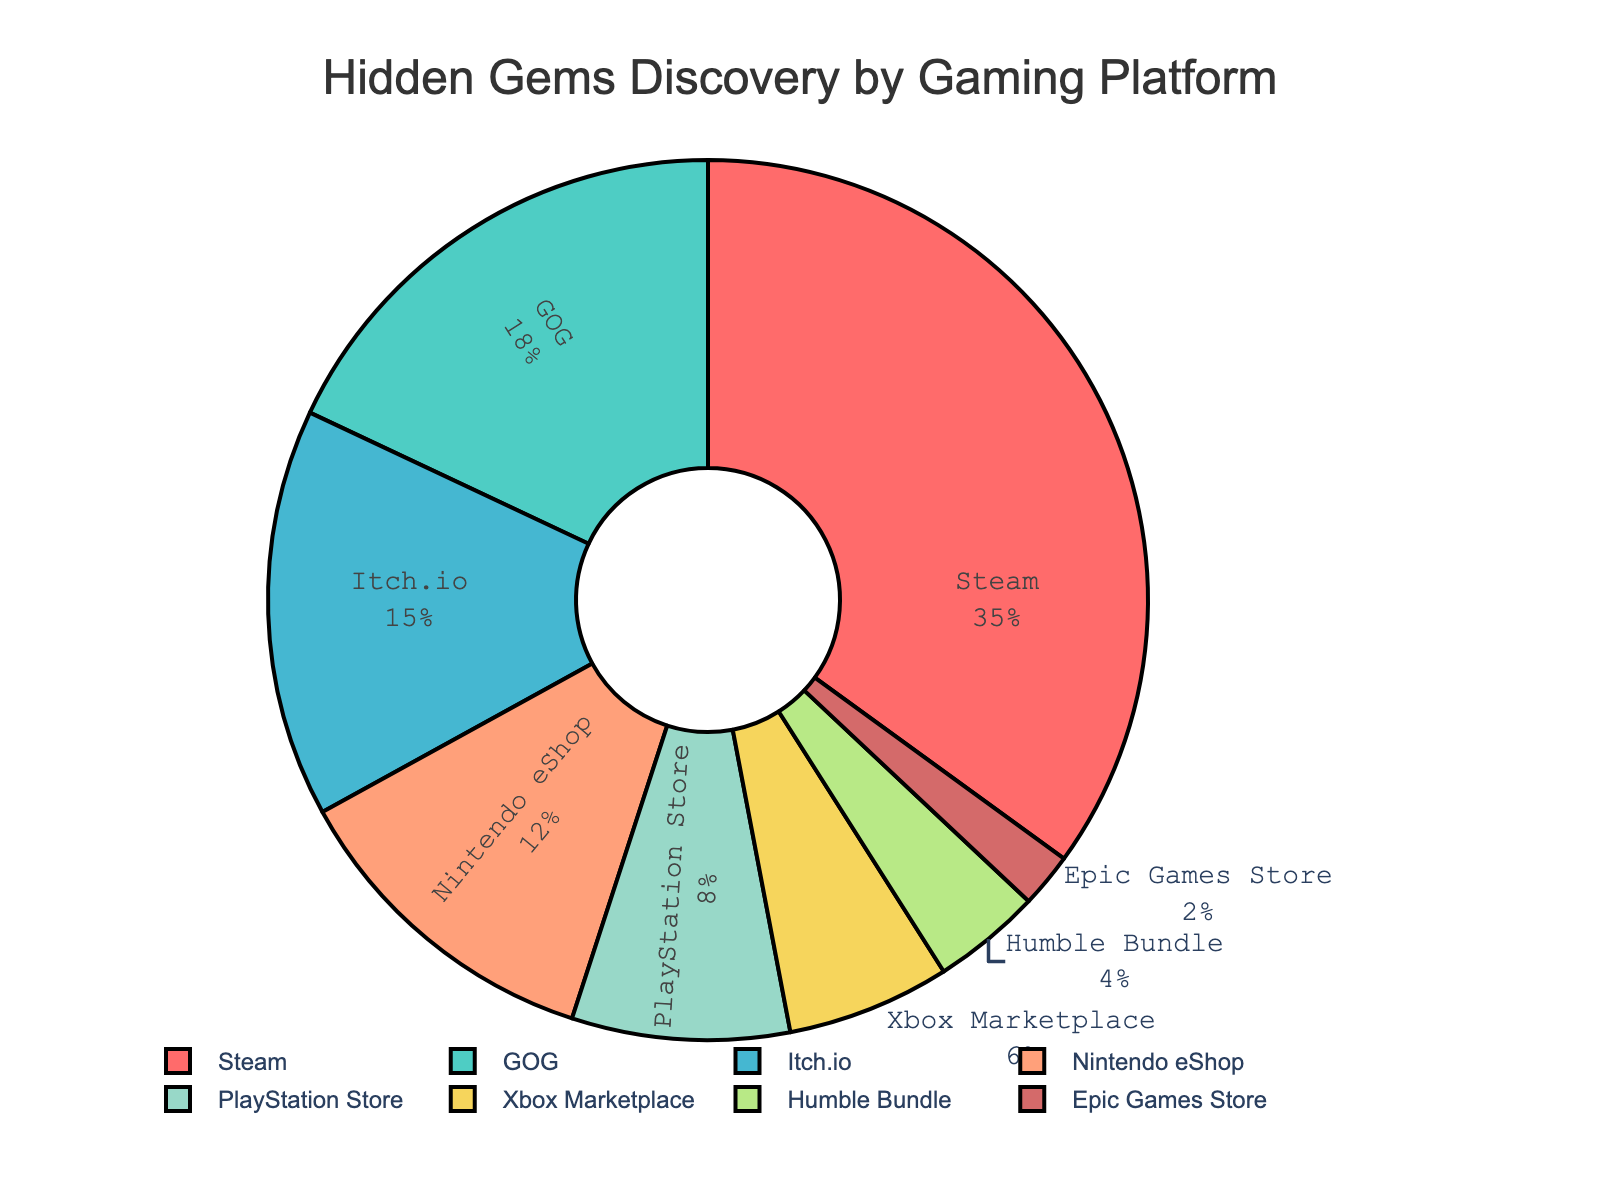Which gaming platform has the highest percentage of hidden gems discovered? The platform with the highest percentage is Steam, which can be seen at the top of the pie chart segments with the label "Steam" and its corresponding percentage.
Answer: Steam Which gaming platform has the lowest percentage of hidden gems discovered? The platform with the lowest percentage is Epic Games Store, which can be seen by identifying the smallest pie chart segment labeled "Epic Games Store".
Answer: Epic Games Store How much more percentage of hidden gems are found on Steam compared to the PlayStation Store? The percentage on Steam is 35% and on PlayStation Store is 8%. Subtracting the two numbers: 35 - 8 = 27.
Answer: 27% What is the combined percentage of hidden gems discovered on GOG, Itch.io, and Humble Bundle platforms? Adding the percentages: GOG (18%) + Itch.io (15%) + Humble Bundle (4%) = 18 + 15 + 4 = 37%.
Answer: 37% Is the combined percentage of hidden gems discovered on Nintendo eShop and Xbox Marketplace greater than the percentage found on Steam? The percentage on Nintendo eShop is 12% and on Xbox Marketplace is 6%. Adding these: 12% + 6% = 18%. Comparing with Steam's 35%, 18% < 35%.
Answer: No Which gaming platforms have a percentage of hidden gems discovered that are greater than 10%? Identifying the platforms with percentages over 10%: Steam (35%), GOG (18%), Itch.io (15%), Nintendo eShop (12%).
Answer: Steam, GOG, Itch.io, Nintendo eShop What is the average percentage of hidden gems discovered across all platforms? Adding all percentages: 35 + 18 + 15 + 12 + 8 + 6 + 4 + 2 = 100. There are 8 platforms, so the average is 100 / 8 = 12.5%.
Answer: 12.5% Which platforms are represented by a red and blue segment respectively in the pie chart? Following the color legend in the code: Red is used for Steam and Blue for Itch.io.
Answer: Steam (red), Itch.io (blue) 